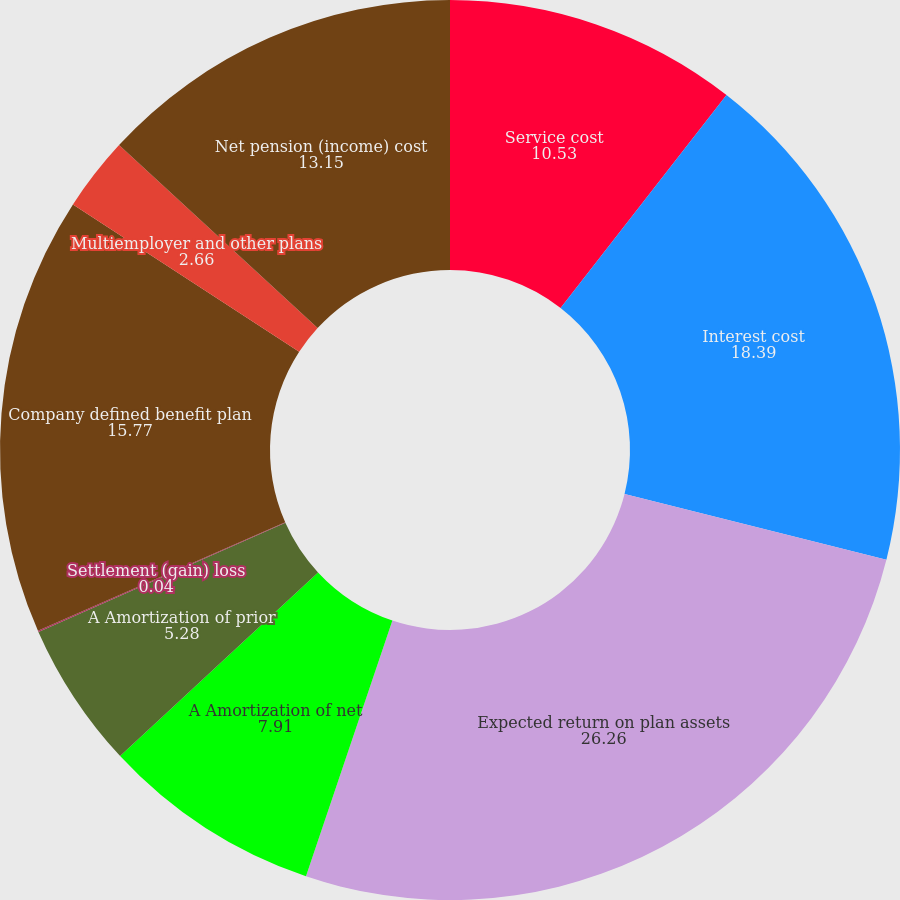<chart> <loc_0><loc_0><loc_500><loc_500><pie_chart><fcel>Service cost<fcel>Interest cost<fcel>Expected return on plan assets<fcel>A Amortization of net<fcel>A Amortization of prior<fcel>Settlement (gain) loss<fcel>Company defined benefit plan<fcel>Multiemployer and other plans<fcel>Net pension (income) cost<nl><fcel>10.53%<fcel>18.39%<fcel>26.26%<fcel>7.91%<fcel>5.28%<fcel>0.04%<fcel>15.77%<fcel>2.66%<fcel>13.15%<nl></chart> 